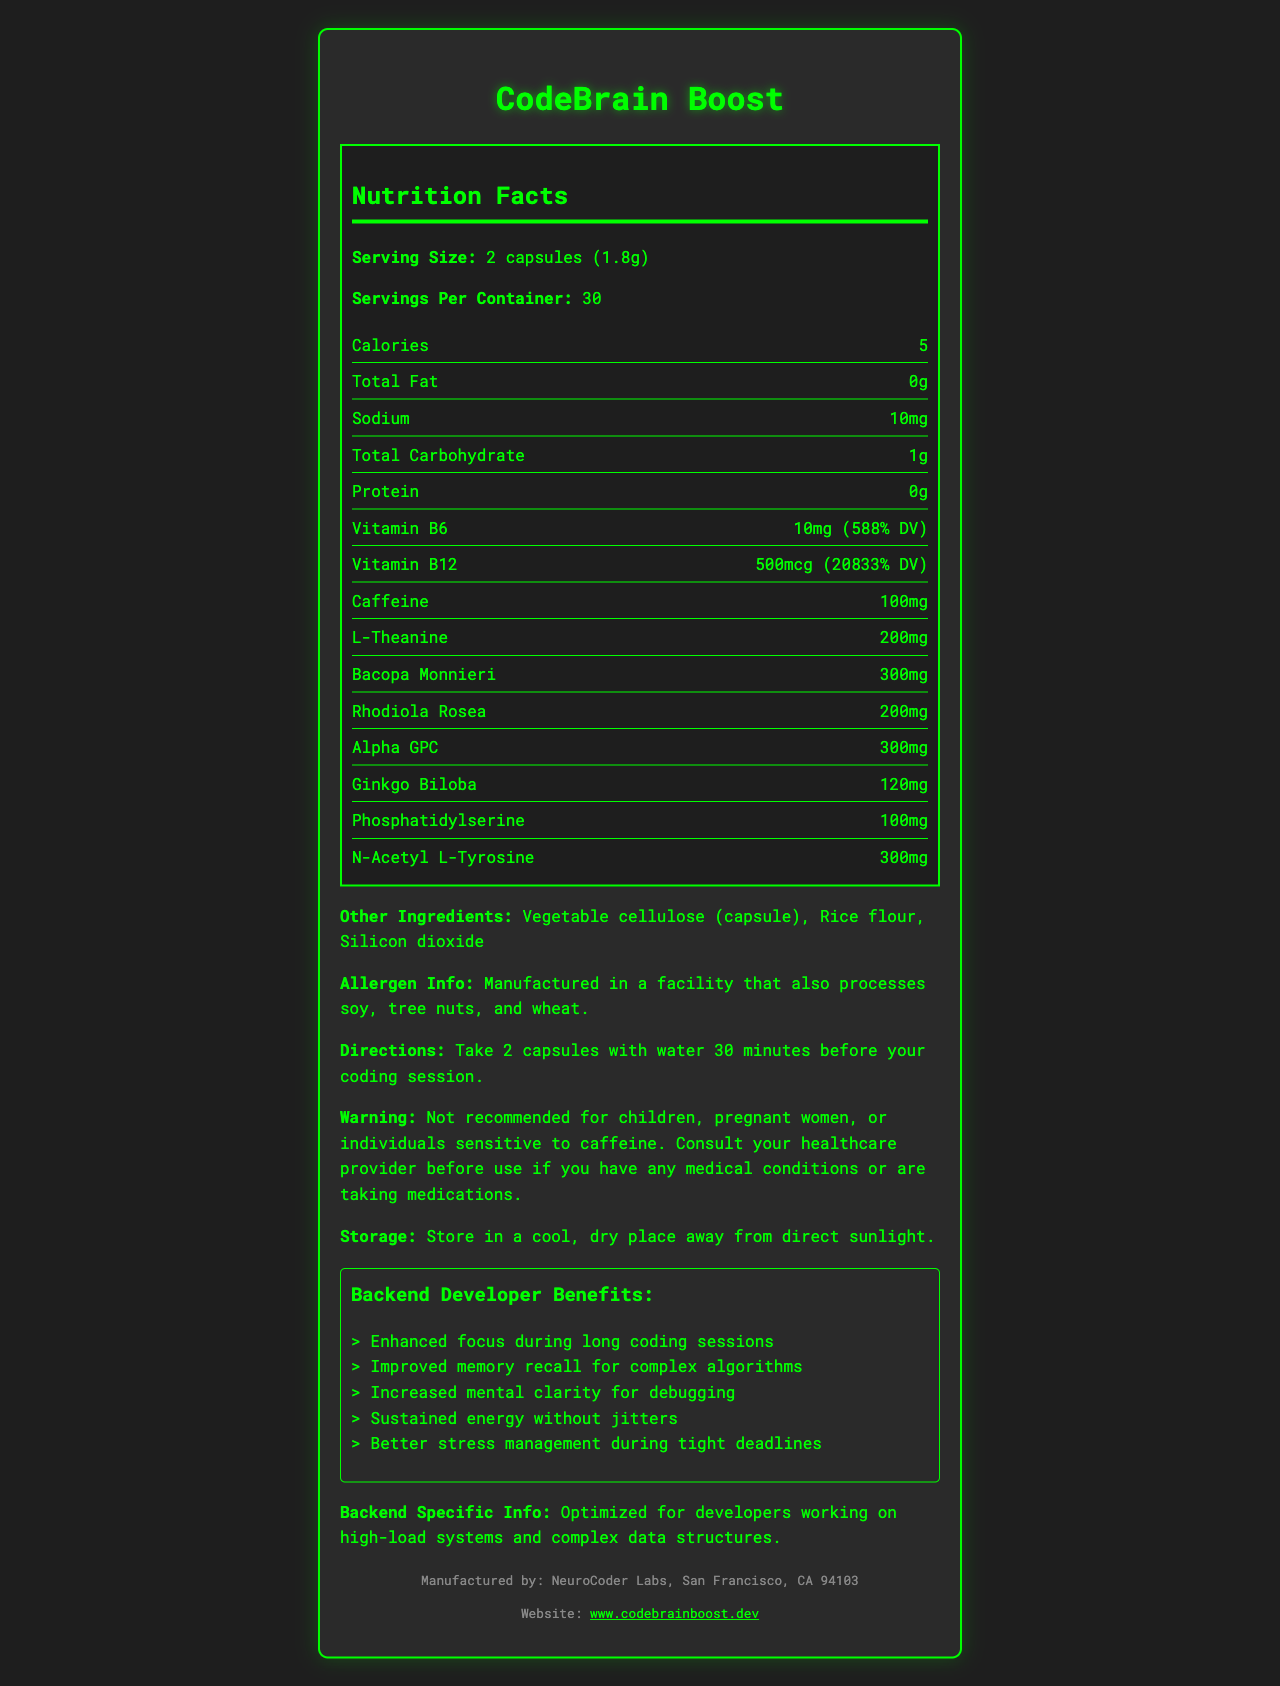what is the product name? The product name is mentioned at the top of the document.
Answer: CodeBrain Boost how many capsules constitute a serving size? The serving size is described as "2 capsules (1.8g)" in the document.
Answer: 2 capsules how many servings are there per container? The information given in the document is "Servings Per Container: 30".
Answer: 30 how much caffeine is present in each serving? The document states that each serving contains 100mg of caffeine.
Answer: 100mg name one ingredient that could potentially cause allergies. The allergen information states that the product is "Manufactured in a facility that also processes soy, tree nuts, and wheat."
Answer: Manufactured in a facility that also processes soy, tree nuts, and wheat which vitamin has a higher daily value percentage, Vitamin B6 or Vitamin B12? Vitamin B12 has a daily value percentage of 20833%, which is higher than the 588% for Vitamin B6.
Answer: Vitamin B12 how much sodium is there in a serving? The document states that there is 10mg of sodium per serving.
Answer: 10mg where should the supplement be stored? The storage directions specify "Store in a cool, dry place away from direct sunlight."
Answer: In a cool, dry place away from direct sunlight is this product recommended for children? The warning clearly states, "Not recommended for children."
Answer: No what is the website to get more information about the product? The website information is listed at the bottom of the document.
Answer: www.codebrainboost.dev what are the benefits of the product for backend developers? The document lists these specific benefits under the developer benefits section.
Answer: Enhanced focus, improved memory recall, increased mental clarity, sustained energy, better stress management which of the following is not an ingredient in CodeBrain Boost? A. Bacopa Monnieri B. Aspartame C. L-Theanine Aspartame is not listed among the ingredients in the document.
Answer: B. Aspartame what could you do if you have a medical condition before taking this supplement? The document advises to "Consult your healthcare provider before use if you have any medical conditions or are taking medications."
Answer: Consult your healthcare provider what is bolded as a specific warning in the document? The warning text includes this specific phrase.
Answer: Not recommended for children, pregnant women, or individuals sensitive to caffeine what should developers do before their coding session? The directions section instructs to take 2 capsules with water, 30 minutes before the coding session.
Answer: Take 2 capsules with water 30 minutes before their coding session summarize the main idea of the document. The document covers various aspects like nutrition facts, developer-specific benefits, and practical information for safe and effective use.
Answer: The document provides detailed nutritional information about CodeBrain Boost, a brain-boosting supplement for developers, including its ingredients, serving size, and benefits, along with storage instructions, warnings, and manufacturer information. how much protein is in each serving? The nutrition label indicates that there is no protein in each serving.
Answer: 0g can the nutrition facts label tell you the dietary fiber content? The document does not mention the amount of dietary fiber included in the supplement.
Answer: Cannot be determined does the document mention the manufacturing location? The document states that the supplement is manufactured by NeuroCoder Labs in San Francisco, CA 94103.
Answer: Yes 